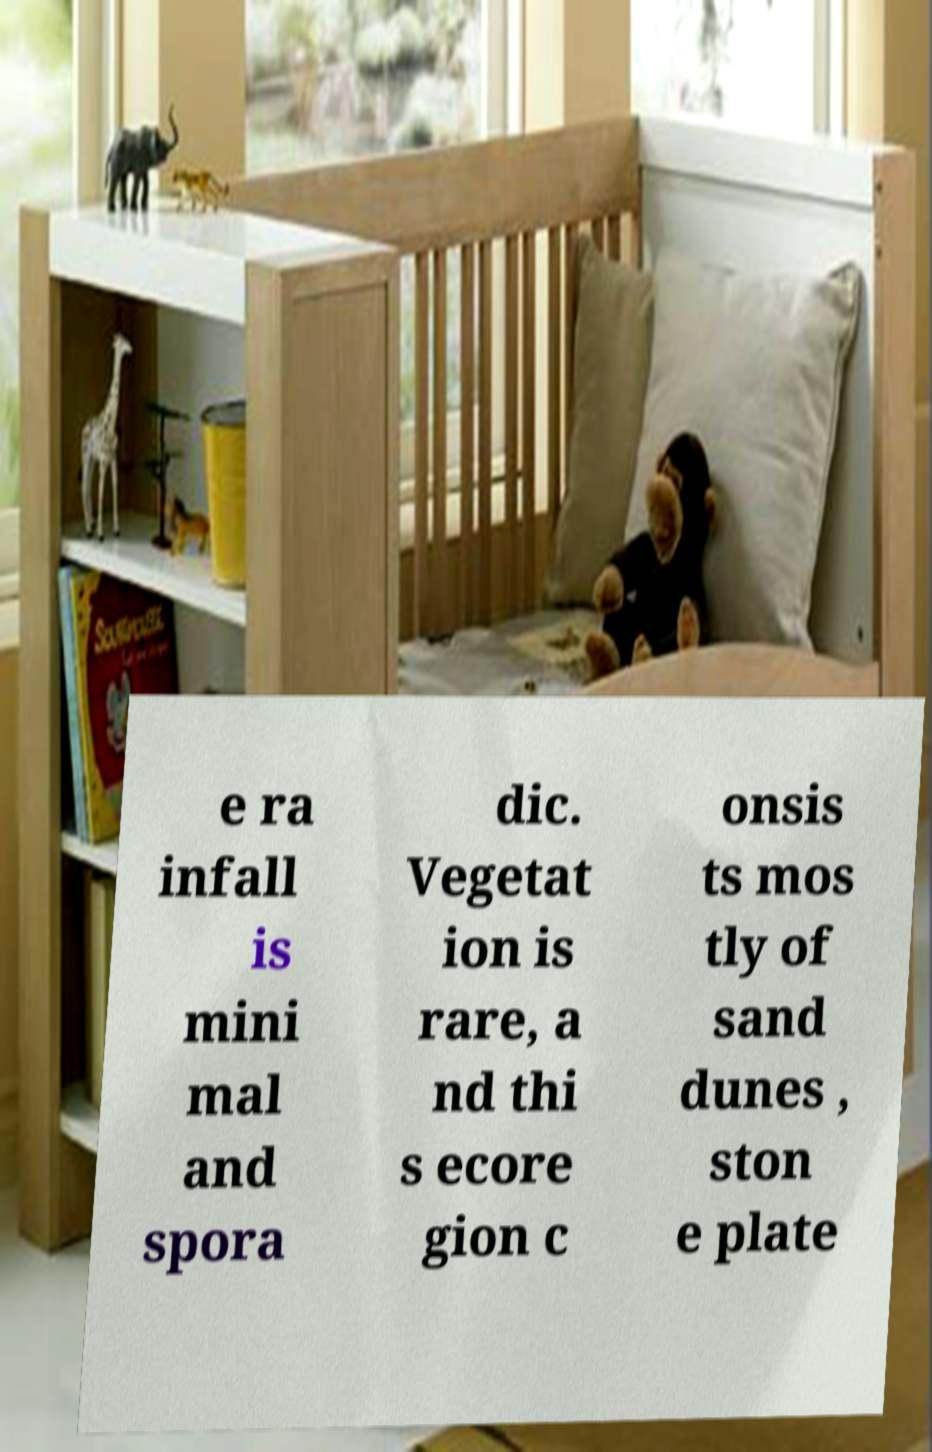Please identify and transcribe the text found in this image. e ra infall is mini mal and spora dic. Vegetat ion is rare, a nd thi s ecore gion c onsis ts mos tly of sand dunes , ston e plate 